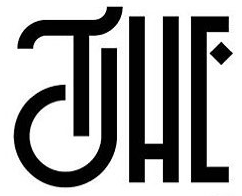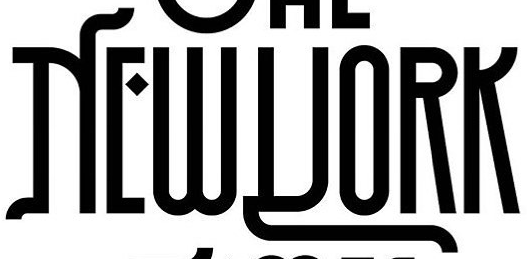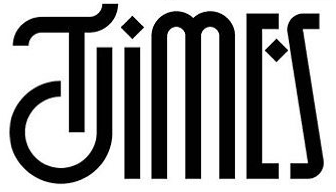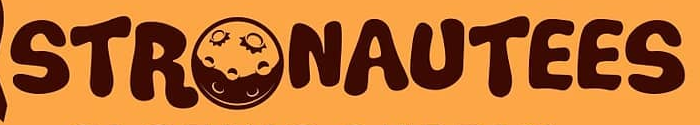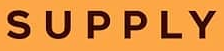What text is displayed in these images sequentially, separated by a semicolon? THE; NEWYORK; TIMES; STRONAUTEES; SUPPLY 